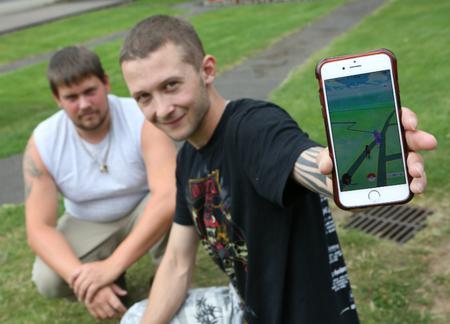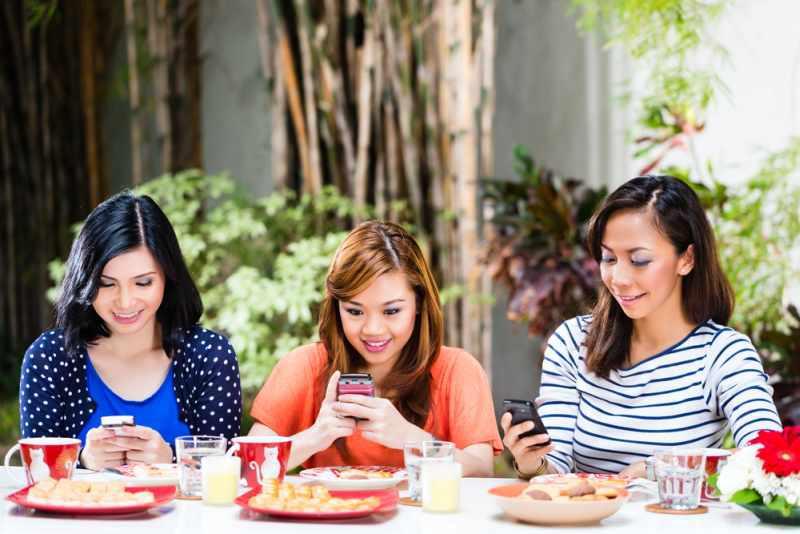The first image is the image on the left, the second image is the image on the right. Evaluate the accuracy of this statement regarding the images: "There are at most five people in the image pair.". Is it true? Answer yes or no. Yes. The first image is the image on the left, the second image is the image on the right. Assess this claim about the two images: "The right image contains no more than three humans holding cell phones.". Correct or not? Answer yes or no. Yes. 